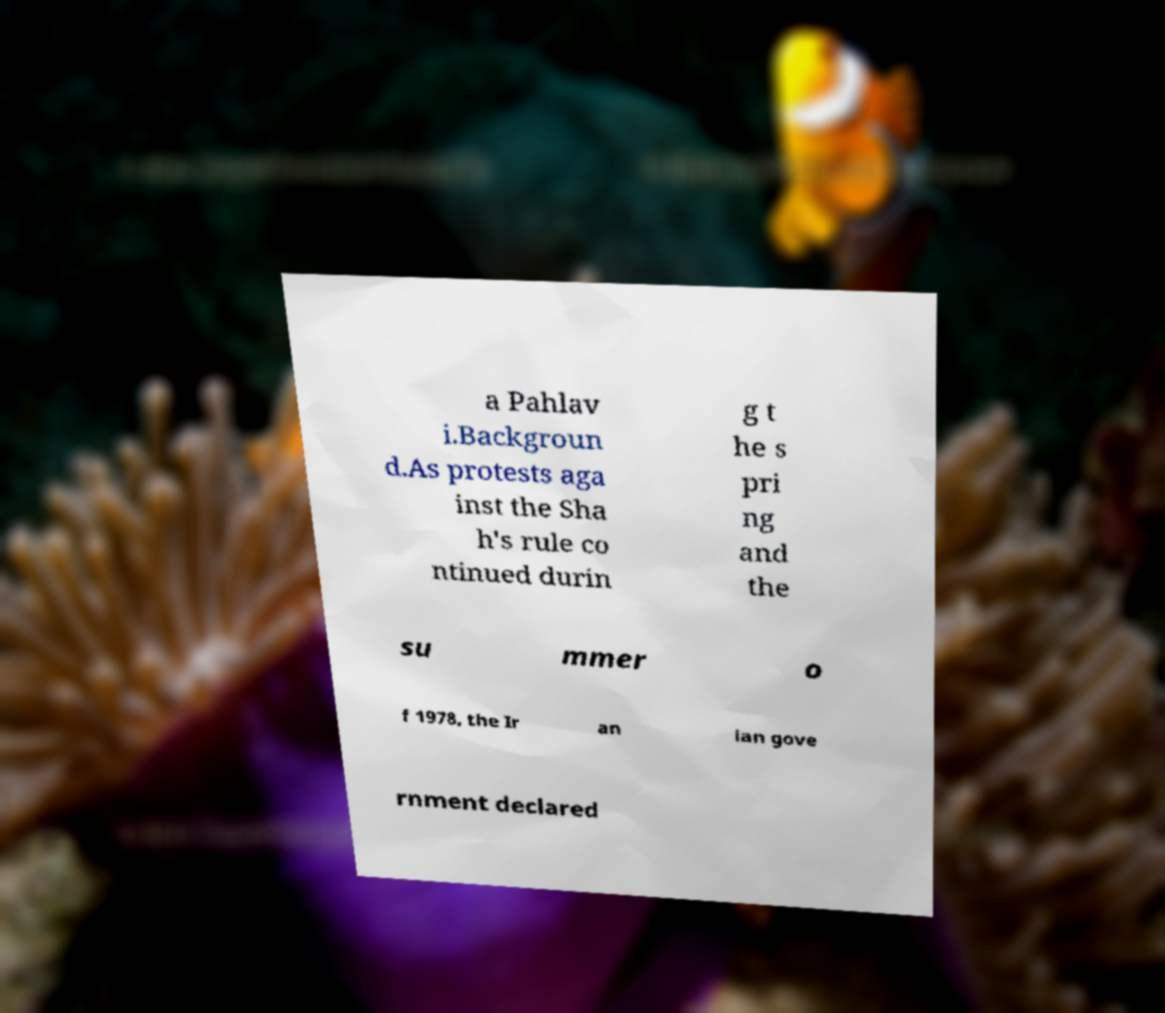Could you extract and type out the text from this image? a Pahlav i.Backgroun d.As protests aga inst the Sha h's rule co ntinued durin g t he s pri ng and the su mmer o f 1978, the Ir an ian gove rnment declared 